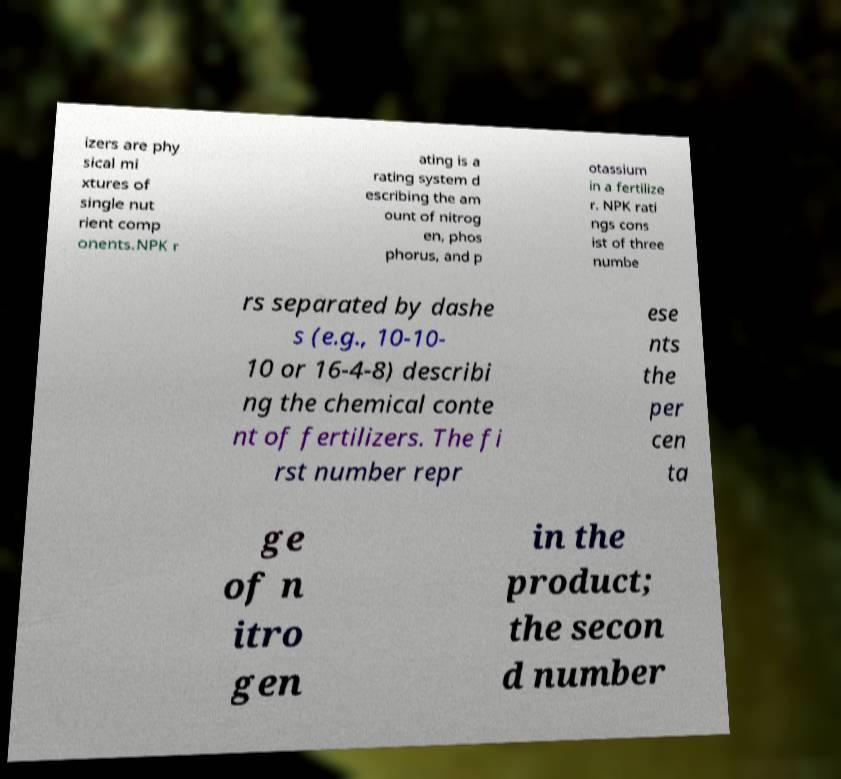I need the written content from this picture converted into text. Can you do that? izers are phy sical mi xtures of single nut rient comp onents.NPK r ating is a rating system d escribing the am ount of nitrog en, phos phorus, and p otassium in a fertilize r. NPK rati ngs cons ist of three numbe rs separated by dashe s (e.g., 10-10- 10 or 16-4-8) describi ng the chemical conte nt of fertilizers. The fi rst number repr ese nts the per cen ta ge of n itro gen in the product; the secon d number 